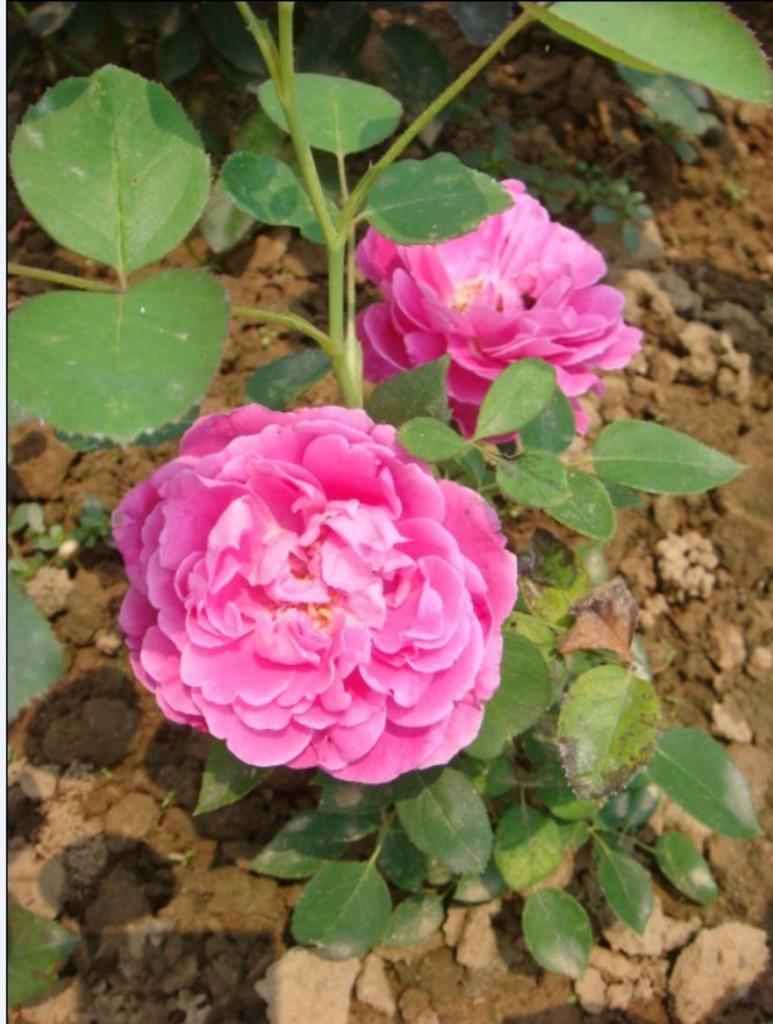What type of living organisms can be seen in the image? Plants and flowers are visible in the image. What part of the natural environment is visible in the image? The ground is visible at the bottom of the image. What grade does the plant receive for its performance in the image? There is no grading system for plants in the image, as plants do not have performance evaluations. 